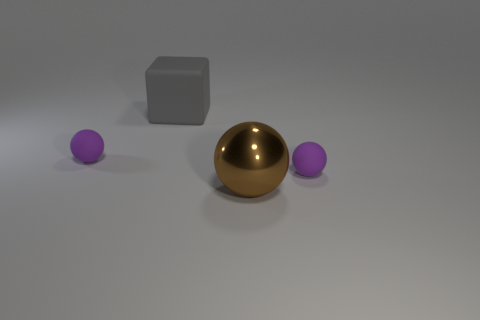Could you speculate on the material the objects are made from based on their appearance? Based on their appearances, the grey block might be made of concrete or stone, the brown ball appears metallic, perhaps bronze, and the purple balls could be either plastic or painted wood due to their matte finish. 